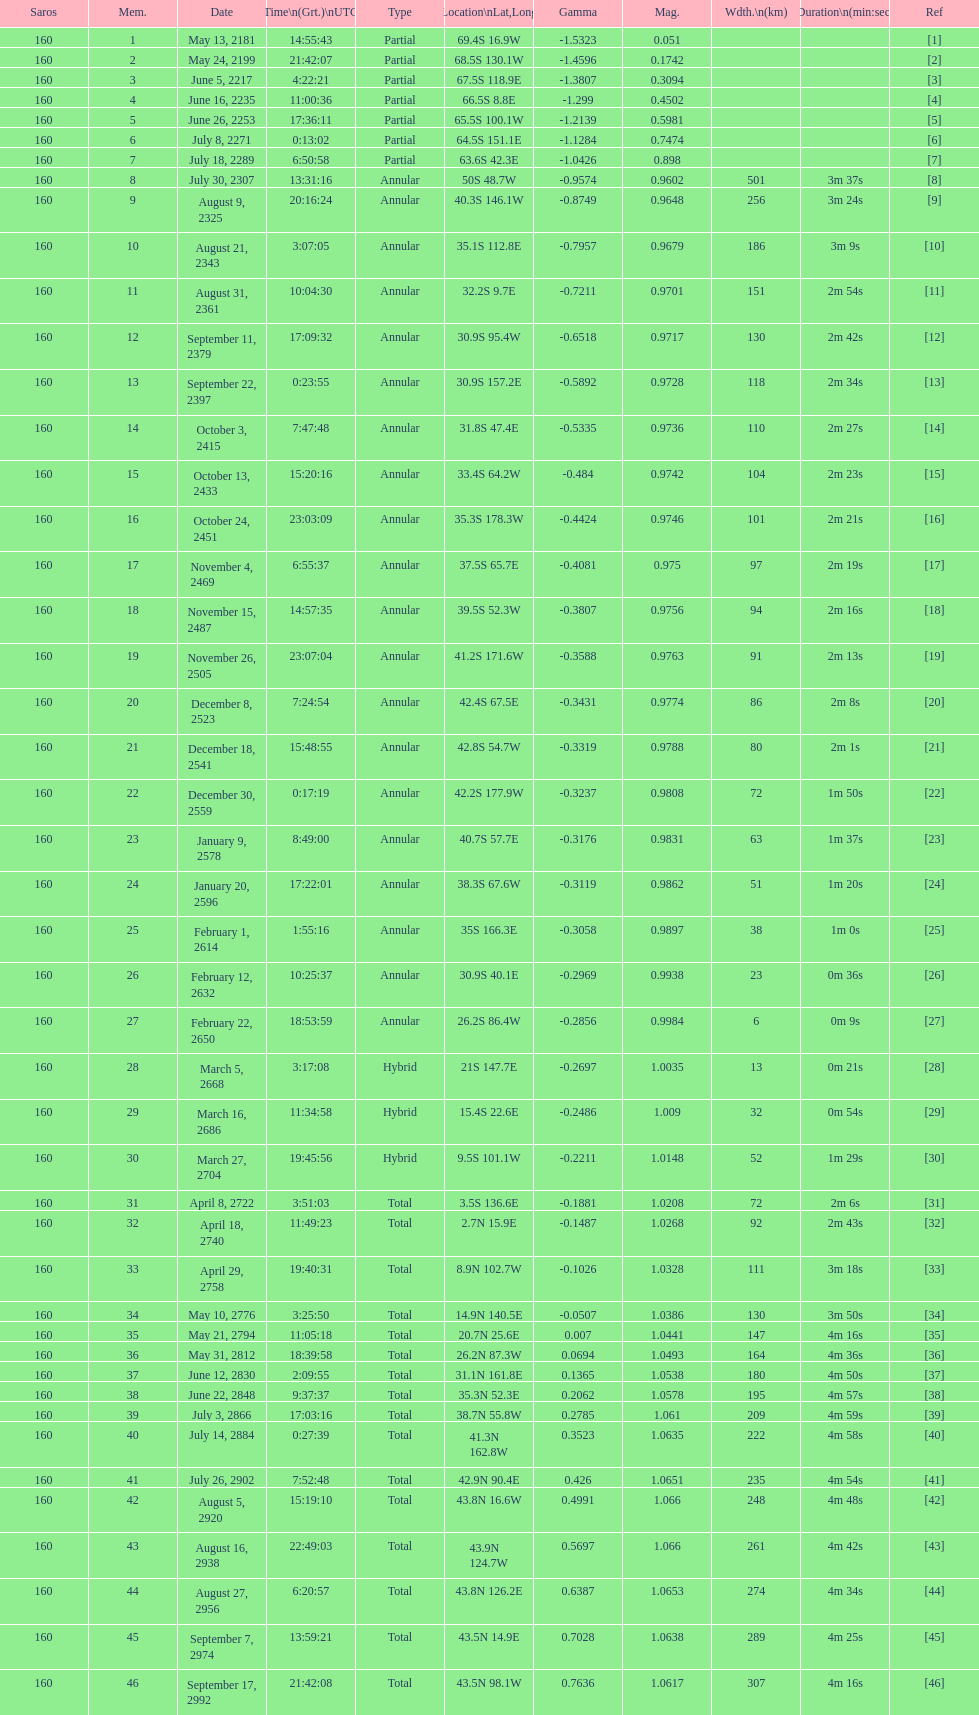After the solar saros on may 24, 2199, when is the next solar saros scheduled? June 5, 2217. 